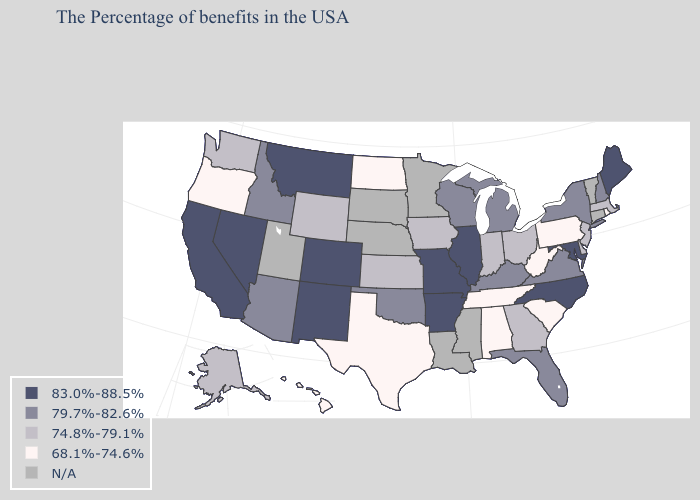Does West Virginia have the lowest value in the USA?
Concise answer only. Yes. Name the states that have a value in the range N/A?
Quick response, please. Vermont, Connecticut, Mississippi, Louisiana, Minnesota, Nebraska, South Dakota, Utah. Is the legend a continuous bar?
Write a very short answer. No. Which states have the lowest value in the Northeast?
Short answer required. Rhode Island, Pennsylvania. What is the highest value in states that border Washington?
Give a very brief answer. 79.7%-82.6%. What is the value of Illinois?
Concise answer only. 83.0%-88.5%. Name the states that have a value in the range 83.0%-88.5%?
Short answer required. Maine, Maryland, North Carolina, Illinois, Missouri, Arkansas, Colorado, New Mexico, Montana, Nevada, California. Which states have the lowest value in the West?
Concise answer only. Oregon, Hawaii. Name the states that have a value in the range 83.0%-88.5%?
Short answer required. Maine, Maryland, North Carolina, Illinois, Missouri, Arkansas, Colorado, New Mexico, Montana, Nevada, California. What is the lowest value in states that border North Dakota?
Concise answer only. 83.0%-88.5%. How many symbols are there in the legend?
Quick response, please. 5. What is the highest value in the USA?
Write a very short answer. 83.0%-88.5%. Does Maine have the highest value in the Northeast?
Be succinct. Yes. What is the lowest value in states that border Maine?
Short answer required. 79.7%-82.6%. 